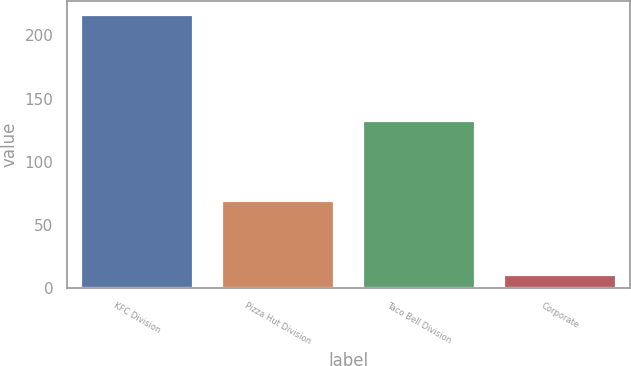<chart> <loc_0><loc_0><loc_500><loc_500><bar_chart><fcel>KFC Division<fcel>Pizza Hut Division<fcel>Taco Bell Division<fcel>Corporate<nl><fcel>216<fcel>69<fcel>132<fcel>10<nl></chart> 